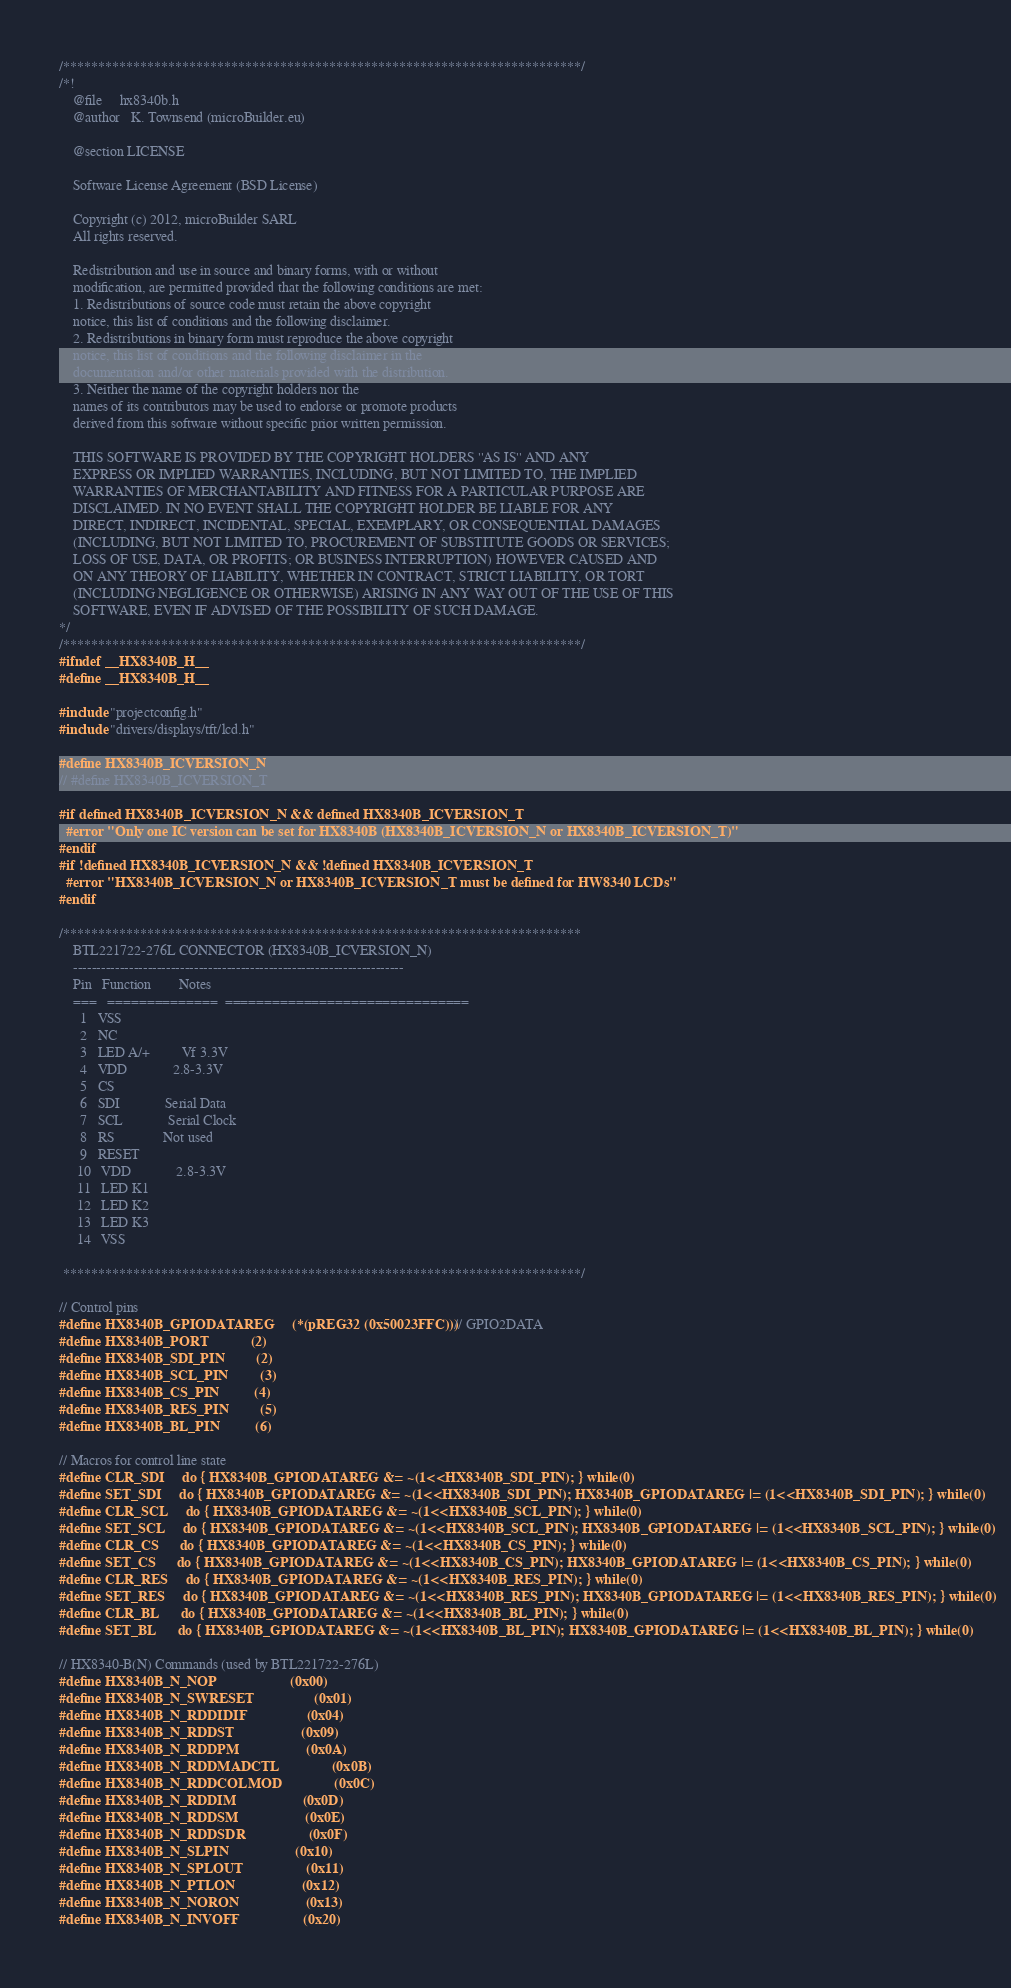<code> <loc_0><loc_0><loc_500><loc_500><_C_>/**************************************************************************/
/*! 
    @file     hx8340b.h
    @author   K. Townsend (microBuilder.eu)

    @section LICENSE

    Software License Agreement (BSD License)

    Copyright (c) 2012, microBuilder SARL
    All rights reserved.

    Redistribution and use in source and binary forms, with or without
    modification, are permitted provided that the following conditions are met:
    1. Redistributions of source code must retain the above copyright
    notice, this list of conditions and the following disclaimer.
    2. Redistributions in binary form must reproduce the above copyright
    notice, this list of conditions and the following disclaimer in the
    documentation and/or other materials provided with the distribution.
    3. Neither the name of the copyright holders nor the
    names of its contributors may be used to endorse or promote products
    derived from this software without specific prior written permission.

    THIS SOFTWARE IS PROVIDED BY THE COPYRIGHT HOLDERS ''AS IS'' AND ANY
    EXPRESS OR IMPLIED WARRANTIES, INCLUDING, BUT NOT LIMITED TO, THE IMPLIED
    WARRANTIES OF MERCHANTABILITY AND FITNESS FOR A PARTICULAR PURPOSE ARE
    DISCLAIMED. IN NO EVENT SHALL THE COPYRIGHT HOLDER BE LIABLE FOR ANY
    DIRECT, INDIRECT, INCIDENTAL, SPECIAL, EXEMPLARY, OR CONSEQUENTIAL DAMAGES
    (INCLUDING, BUT NOT LIMITED TO, PROCUREMENT OF SUBSTITUTE GOODS OR SERVICES;
    LOSS OF USE, DATA, OR PROFITS; OR BUSINESS INTERRUPTION) HOWEVER CAUSED AND
    ON ANY THEORY OF LIABILITY, WHETHER IN CONTRACT, STRICT LIABILITY, OR TORT
    (INCLUDING NEGLIGENCE OR OTHERWISE) ARISING IN ANY WAY OUT OF THE USE OF THIS
    SOFTWARE, EVEN IF ADVISED OF THE POSSIBILITY OF SUCH DAMAGE.
*/
/**************************************************************************/
#ifndef __HX8340B_H__
#define __HX8340B_H__

#include "projectconfig.h"
#include "drivers/displays/tft/lcd.h"

#define HX8340B_ICVERSION_N
// #define HX8340B_ICVERSION_T

#if defined HX8340B_ICVERSION_N && defined HX8340B_ICVERSION_T
  #error "Only one IC version can be set for HX8340B (HX8340B_ICVERSION_N or HX8340B_ICVERSION_T)"
#endif
#if !defined HX8340B_ICVERSION_N && !defined HX8340B_ICVERSION_T
  #error "HX8340B_ICVERSION_N or HX8340B_ICVERSION_T must be defined for HW8340 LCDs"
#endif

/**************************************************************************
    BTL221722-276L CONNECTOR (HX8340B_ICVERSION_N)
    -----------------------------------------------------------------------
    Pin   Function        Notes
    ===   ==============  ===============================
      1   VSS
      2   NC
      3   LED A/+         Vf 3.3V
      4   VDD             2.8-3.3V
      5   CS
      6   SDI             Serial Data
      7   SCL             Serial Clock
      8   RS              Not used
      9   RESET
     10   VDD             2.8-3.3V
     11   LED K1
     12   LED K2
     13   LED K3
     14   VSS

 **************************************************************************/

// Control pins
#define HX8340B_GPIODATAREG     (*(pREG32 (0x50023FFC)))   // GPIO2DATA
#define HX8340B_PORT            (2)
#define HX8340B_SDI_PIN         (2)
#define HX8340B_SCL_PIN         (3)
#define HX8340B_CS_PIN          (4)
#define HX8340B_RES_PIN         (5)
#define HX8340B_BL_PIN          (6)

// Macros for control line state
#define CLR_SDI     do { HX8340B_GPIODATAREG &= ~(1<<HX8340B_SDI_PIN); } while(0)
#define SET_SDI     do { HX8340B_GPIODATAREG &= ~(1<<HX8340B_SDI_PIN); HX8340B_GPIODATAREG |= (1<<HX8340B_SDI_PIN); } while(0)
#define CLR_SCL     do { HX8340B_GPIODATAREG &= ~(1<<HX8340B_SCL_PIN); } while(0)
#define SET_SCL     do { HX8340B_GPIODATAREG &= ~(1<<HX8340B_SCL_PIN); HX8340B_GPIODATAREG |= (1<<HX8340B_SCL_PIN); } while(0)
#define CLR_CS      do { HX8340B_GPIODATAREG &= ~(1<<HX8340B_CS_PIN); } while(0)
#define SET_CS      do { HX8340B_GPIODATAREG &= ~(1<<HX8340B_CS_PIN); HX8340B_GPIODATAREG |= (1<<HX8340B_CS_PIN); } while(0)
#define CLR_RES     do { HX8340B_GPIODATAREG &= ~(1<<HX8340B_RES_PIN); } while(0)
#define SET_RES     do { HX8340B_GPIODATAREG &= ~(1<<HX8340B_RES_PIN); HX8340B_GPIODATAREG |= (1<<HX8340B_RES_PIN); } while(0)
#define CLR_BL      do { HX8340B_GPIODATAREG &= ~(1<<HX8340B_BL_PIN); } while(0)
#define SET_BL      do { HX8340B_GPIODATAREG &= ~(1<<HX8340B_BL_PIN); HX8340B_GPIODATAREG |= (1<<HX8340B_BL_PIN); } while(0)

// HX8340-B(N) Commands (used by BTL221722-276L)
#define HX8340B_N_NOP                     (0x00)
#define HX8340B_N_SWRESET                 (0x01)
#define HX8340B_N_RDDIDIF                 (0x04)
#define HX8340B_N_RDDST                   (0x09)
#define HX8340B_N_RDDPM                   (0x0A)
#define HX8340B_N_RDDMADCTL               (0x0B)
#define HX8340B_N_RDDCOLMOD               (0x0C)
#define HX8340B_N_RDDIM                   (0x0D)
#define HX8340B_N_RDDSM                   (0x0E)
#define HX8340B_N_RDDSDR                  (0x0F)
#define HX8340B_N_SLPIN                   (0x10)
#define HX8340B_N_SPLOUT                  (0x11)
#define HX8340B_N_PTLON                   (0x12)
#define HX8340B_N_NORON                   (0x13)
#define HX8340B_N_INVOFF                  (0x20)</code> 